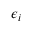Convert formula to latex. <formula><loc_0><loc_0><loc_500><loc_500>\epsilon _ { i }</formula> 